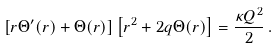<formula> <loc_0><loc_0><loc_500><loc_500>\left [ r \Theta ^ { \prime } ( r ) + \Theta ( r ) \right ] \left [ r ^ { 2 } + 2 q \Theta ( r ) \right ] = \frac { \kappa Q ^ { 2 } } { 2 } \, .</formula> 